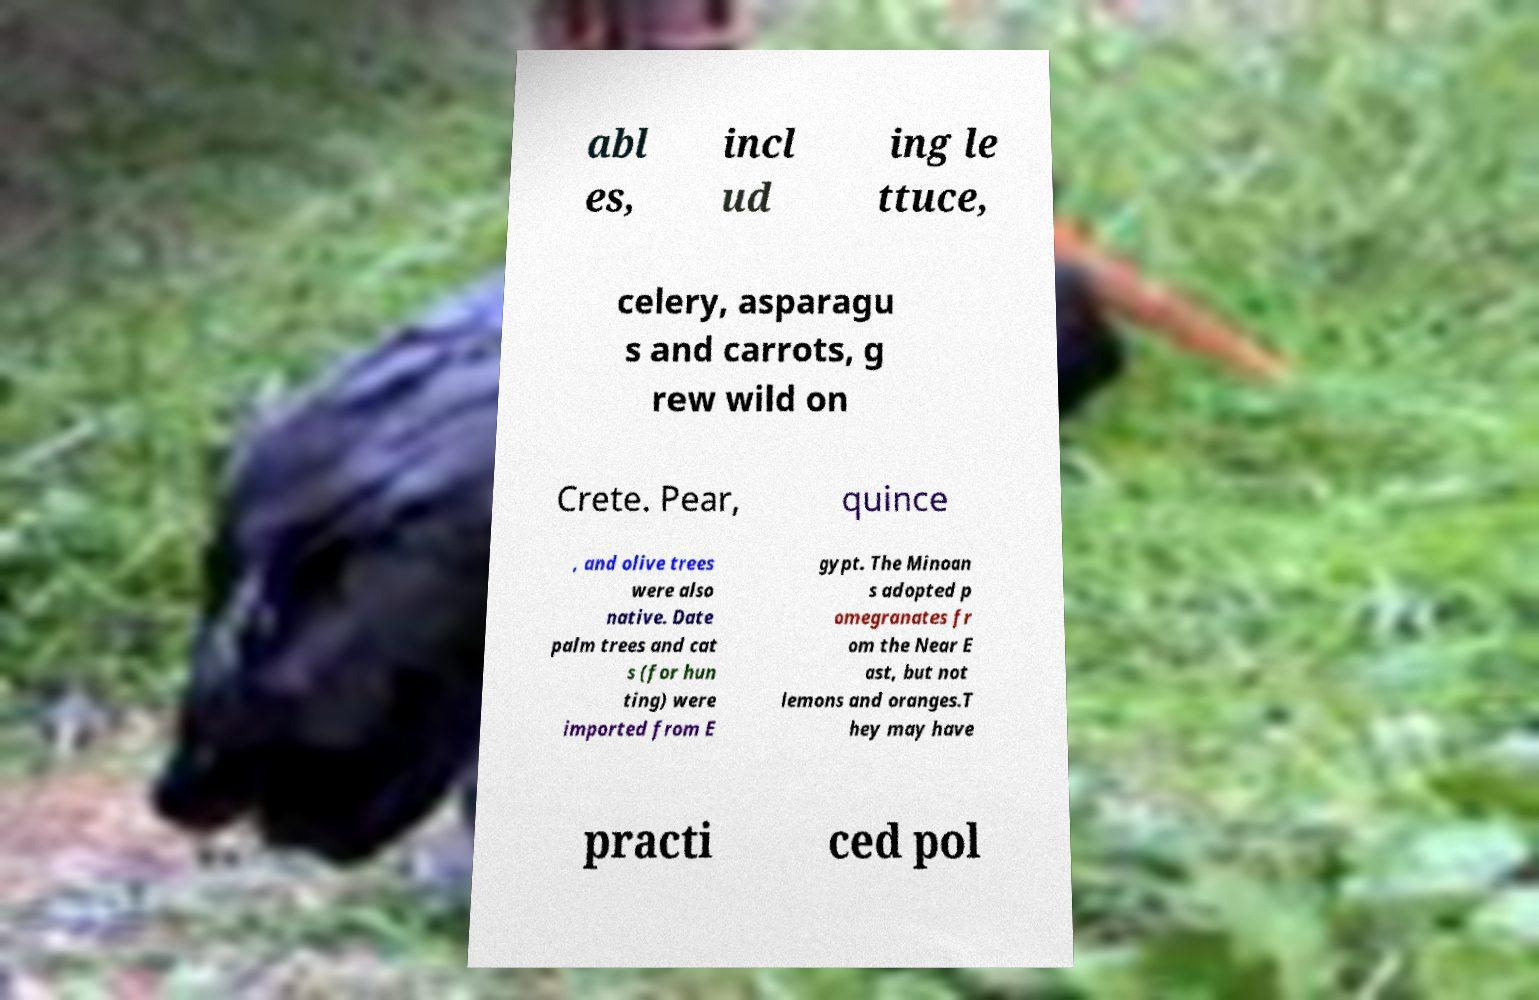Could you assist in decoding the text presented in this image and type it out clearly? abl es, incl ud ing le ttuce, celery, asparagu s and carrots, g rew wild on Crete. Pear, quince , and olive trees were also native. Date palm trees and cat s (for hun ting) were imported from E gypt. The Minoan s adopted p omegranates fr om the Near E ast, but not lemons and oranges.T hey may have practi ced pol 